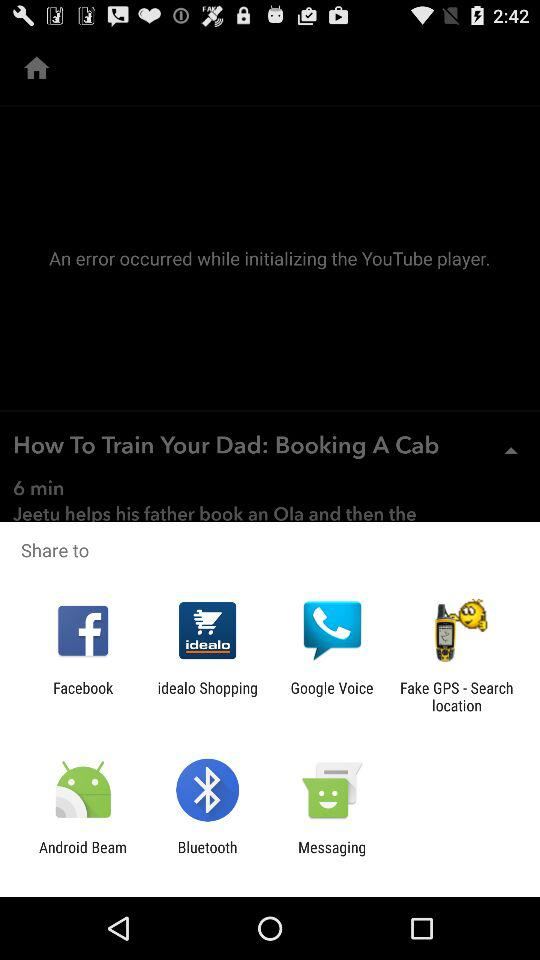Which are the different sharing options? The different sharing options are "Facebook", "idealo Shopping", "Google Voice", "Fake GPS - Search location", "Android Beam", "Bluetooth" and "Messaging". 